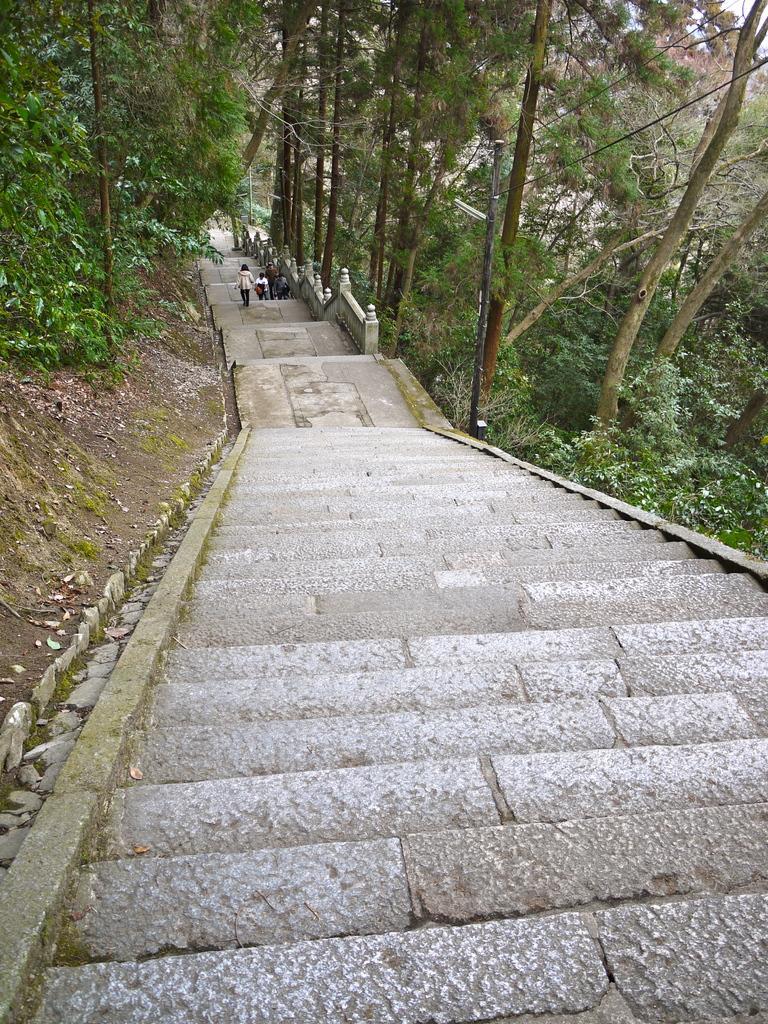Could you give a brief overview of what you see in this image? This picture is clicked outside. In the center we can see the stairway and we can see the group of persons. On both the sides we can see the plants and trees. 